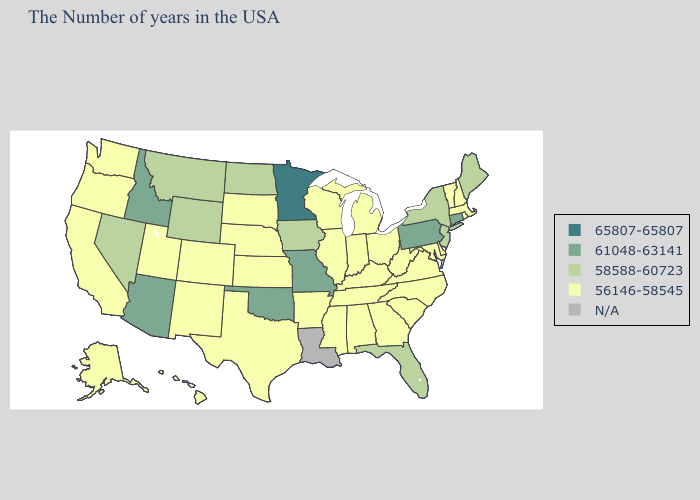How many symbols are there in the legend?
Answer briefly. 5. Does Rhode Island have the highest value in the Northeast?
Answer briefly. No. Which states hav the highest value in the West?
Concise answer only. Arizona, Idaho. Among the states that border Colorado , does Nebraska have the highest value?
Be succinct. No. Among the states that border Montana , does Idaho have the highest value?
Concise answer only. Yes. What is the value of Minnesota?
Concise answer only. 65807-65807. Name the states that have a value in the range 65807-65807?
Give a very brief answer. Minnesota. Name the states that have a value in the range N/A?
Give a very brief answer. Louisiana. What is the value of Michigan?
Concise answer only. 56146-58545. Does New York have the highest value in the Northeast?
Concise answer only. No. What is the lowest value in states that border Nevada?
Concise answer only. 56146-58545. Which states hav the highest value in the West?
Keep it brief. Arizona, Idaho. Name the states that have a value in the range 65807-65807?
Keep it brief. Minnesota. What is the value of South Dakota?
Be succinct. 56146-58545. 